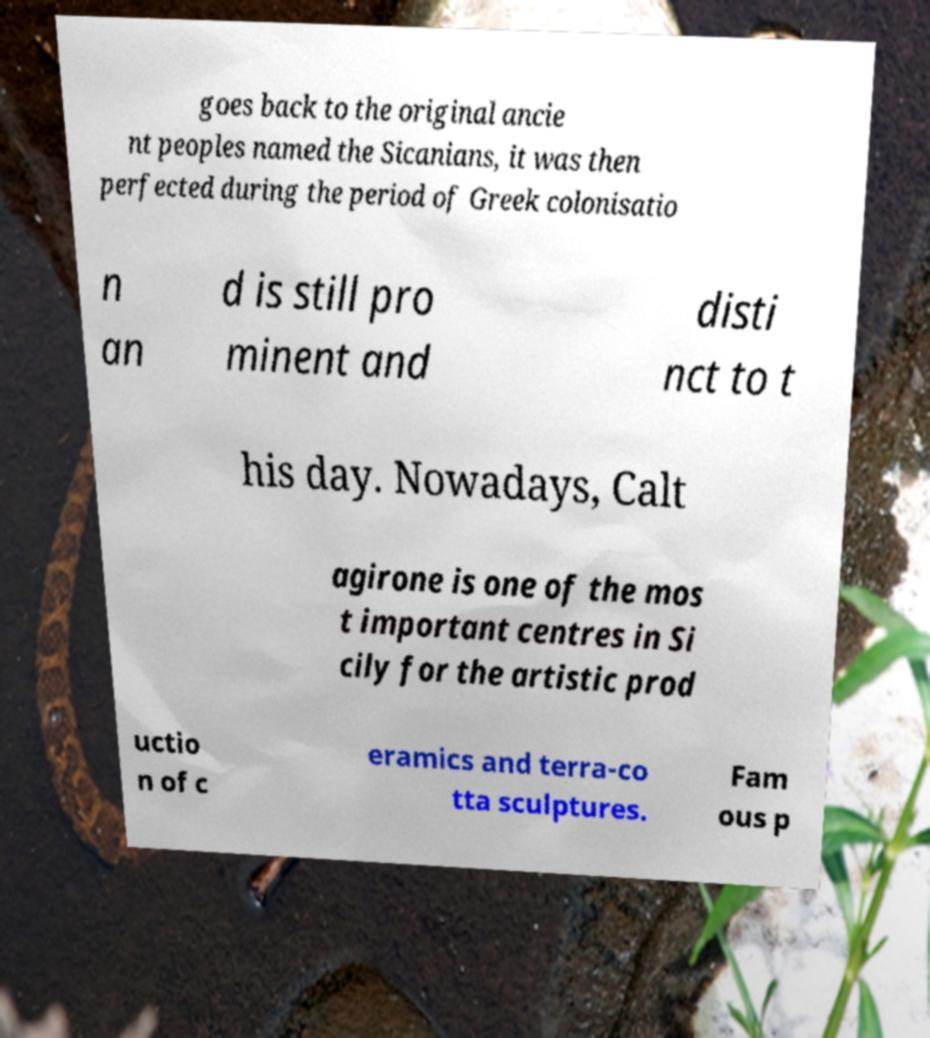Could you extract and type out the text from this image? goes back to the original ancie nt peoples named the Sicanians, it was then perfected during the period of Greek colonisatio n an d is still pro minent and disti nct to t his day. Nowadays, Calt agirone is one of the mos t important centres in Si cily for the artistic prod uctio n of c eramics and terra-co tta sculptures. Fam ous p 